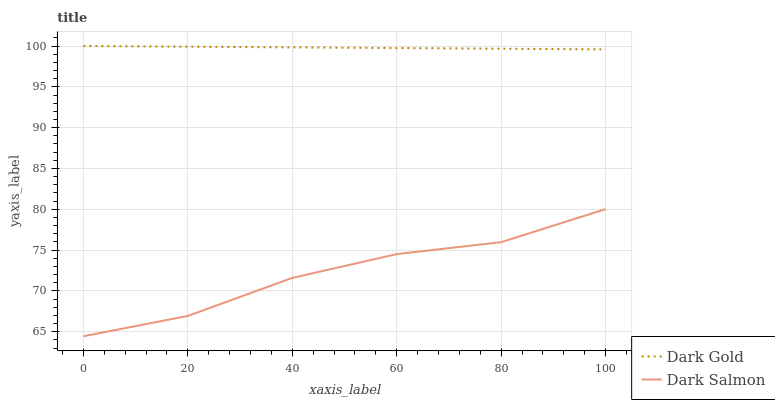Does Dark Salmon have the minimum area under the curve?
Answer yes or no. Yes. Does Dark Gold have the maximum area under the curve?
Answer yes or no. Yes. Does Dark Gold have the minimum area under the curve?
Answer yes or no. No. Is Dark Gold the smoothest?
Answer yes or no. Yes. Is Dark Salmon the roughest?
Answer yes or no. Yes. Is Dark Gold the roughest?
Answer yes or no. No. Does Dark Salmon have the lowest value?
Answer yes or no. Yes. Does Dark Gold have the lowest value?
Answer yes or no. No. Does Dark Gold have the highest value?
Answer yes or no. Yes. Is Dark Salmon less than Dark Gold?
Answer yes or no. Yes. Is Dark Gold greater than Dark Salmon?
Answer yes or no. Yes. Does Dark Salmon intersect Dark Gold?
Answer yes or no. No. 